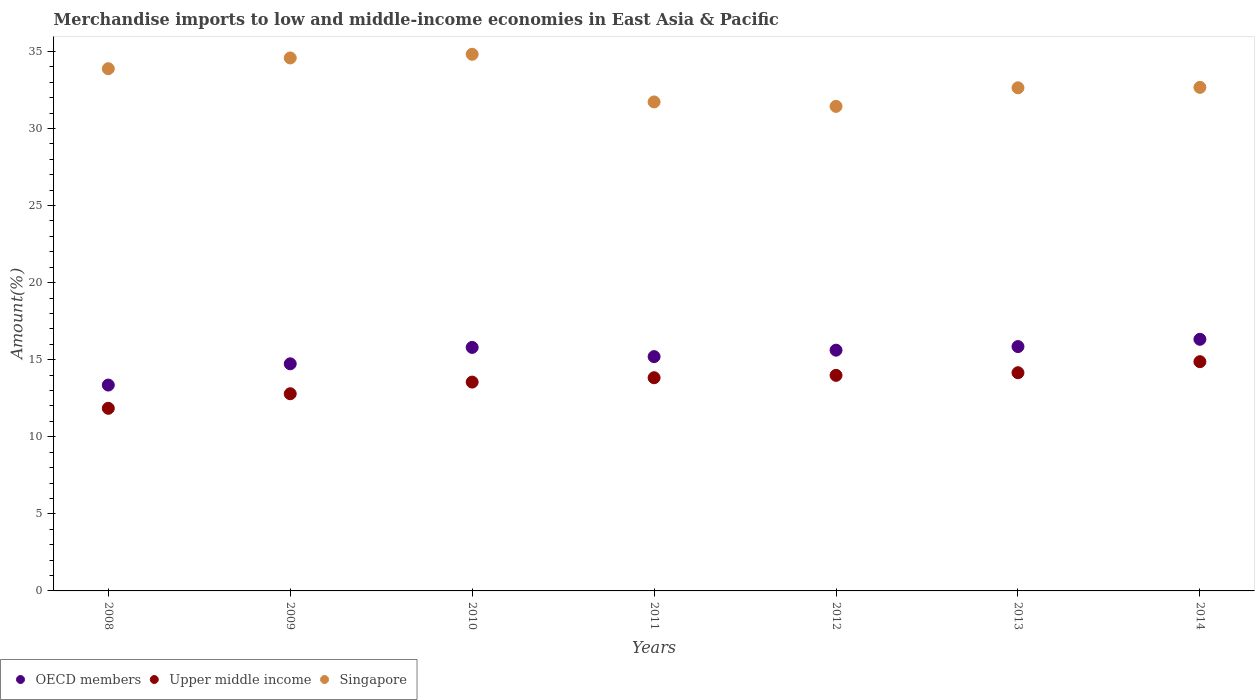Is the number of dotlines equal to the number of legend labels?
Provide a succinct answer. Yes. What is the percentage of amount earned from merchandise imports in Singapore in 2012?
Offer a terse response. 31.43. Across all years, what is the maximum percentage of amount earned from merchandise imports in OECD members?
Make the answer very short. 16.32. Across all years, what is the minimum percentage of amount earned from merchandise imports in Singapore?
Your answer should be very brief. 31.43. In which year was the percentage of amount earned from merchandise imports in Singapore maximum?
Ensure brevity in your answer.  2010. In which year was the percentage of amount earned from merchandise imports in OECD members minimum?
Your answer should be compact. 2008. What is the total percentage of amount earned from merchandise imports in OECD members in the graph?
Offer a terse response. 106.87. What is the difference between the percentage of amount earned from merchandise imports in OECD members in 2010 and that in 2011?
Provide a succinct answer. 0.6. What is the difference between the percentage of amount earned from merchandise imports in Upper middle income in 2012 and the percentage of amount earned from merchandise imports in OECD members in 2009?
Keep it short and to the point. -0.75. What is the average percentage of amount earned from merchandise imports in OECD members per year?
Give a very brief answer. 15.27. In the year 2008, what is the difference between the percentage of amount earned from merchandise imports in Singapore and percentage of amount earned from merchandise imports in Upper middle income?
Your answer should be very brief. 22.03. What is the ratio of the percentage of amount earned from merchandise imports in Upper middle income in 2010 to that in 2011?
Provide a succinct answer. 0.98. What is the difference between the highest and the second highest percentage of amount earned from merchandise imports in OECD members?
Your answer should be compact. 0.47. What is the difference between the highest and the lowest percentage of amount earned from merchandise imports in Singapore?
Ensure brevity in your answer.  3.38. Does the percentage of amount earned from merchandise imports in OECD members monotonically increase over the years?
Your answer should be very brief. No. Is the percentage of amount earned from merchandise imports in OECD members strictly greater than the percentage of amount earned from merchandise imports in Singapore over the years?
Provide a succinct answer. No. Is the percentage of amount earned from merchandise imports in Upper middle income strictly less than the percentage of amount earned from merchandise imports in Singapore over the years?
Your answer should be compact. Yes. How many dotlines are there?
Your response must be concise. 3. How are the legend labels stacked?
Your answer should be very brief. Horizontal. What is the title of the graph?
Your answer should be very brief. Merchandise imports to low and middle-income economies in East Asia & Pacific. What is the label or title of the Y-axis?
Ensure brevity in your answer.  Amount(%). What is the Amount(%) in OECD members in 2008?
Your answer should be compact. 13.35. What is the Amount(%) of Upper middle income in 2008?
Give a very brief answer. 11.85. What is the Amount(%) in Singapore in 2008?
Ensure brevity in your answer.  33.87. What is the Amount(%) in OECD members in 2009?
Your answer should be compact. 14.73. What is the Amount(%) of Upper middle income in 2009?
Your answer should be compact. 12.79. What is the Amount(%) in Singapore in 2009?
Give a very brief answer. 34.57. What is the Amount(%) in OECD members in 2010?
Offer a very short reply. 15.8. What is the Amount(%) of Upper middle income in 2010?
Your answer should be compact. 13.55. What is the Amount(%) in Singapore in 2010?
Your response must be concise. 34.81. What is the Amount(%) of OECD members in 2011?
Make the answer very short. 15.2. What is the Amount(%) of Upper middle income in 2011?
Your answer should be very brief. 13.83. What is the Amount(%) in Singapore in 2011?
Keep it short and to the point. 31.72. What is the Amount(%) of OECD members in 2012?
Provide a succinct answer. 15.62. What is the Amount(%) of Upper middle income in 2012?
Ensure brevity in your answer.  13.98. What is the Amount(%) of Singapore in 2012?
Give a very brief answer. 31.43. What is the Amount(%) in OECD members in 2013?
Your answer should be compact. 15.85. What is the Amount(%) of Upper middle income in 2013?
Provide a succinct answer. 14.15. What is the Amount(%) in Singapore in 2013?
Offer a very short reply. 32.63. What is the Amount(%) of OECD members in 2014?
Make the answer very short. 16.32. What is the Amount(%) in Upper middle income in 2014?
Make the answer very short. 14.87. What is the Amount(%) of Singapore in 2014?
Your response must be concise. 32.66. Across all years, what is the maximum Amount(%) in OECD members?
Give a very brief answer. 16.32. Across all years, what is the maximum Amount(%) of Upper middle income?
Offer a terse response. 14.87. Across all years, what is the maximum Amount(%) of Singapore?
Provide a succinct answer. 34.81. Across all years, what is the minimum Amount(%) in OECD members?
Ensure brevity in your answer.  13.35. Across all years, what is the minimum Amount(%) in Upper middle income?
Ensure brevity in your answer.  11.85. Across all years, what is the minimum Amount(%) of Singapore?
Make the answer very short. 31.43. What is the total Amount(%) in OECD members in the graph?
Your answer should be very brief. 106.87. What is the total Amount(%) in Upper middle income in the graph?
Your answer should be compact. 95.02. What is the total Amount(%) in Singapore in the graph?
Your response must be concise. 231.7. What is the difference between the Amount(%) in OECD members in 2008 and that in 2009?
Make the answer very short. -1.38. What is the difference between the Amount(%) of Upper middle income in 2008 and that in 2009?
Make the answer very short. -0.94. What is the difference between the Amount(%) in Singapore in 2008 and that in 2009?
Give a very brief answer. -0.7. What is the difference between the Amount(%) in OECD members in 2008 and that in 2010?
Give a very brief answer. -2.44. What is the difference between the Amount(%) in Upper middle income in 2008 and that in 2010?
Keep it short and to the point. -1.7. What is the difference between the Amount(%) of Singapore in 2008 and that in 2010?
Make the answer very short. -0.94. What is the difference between the Amount(%) in OECD members in 2008 and that in 2011?
Provide a short and direct response. -1.84. What is the difference between the Amount(%) in Upper middle income in 2008 and that in 2011?
Your answer should be compact. -1.98. What is the difference between the Amount(%) in Singapore in 2008 and that in 2011?
Keep it short and to the point. 2.16. What is the difference between the Amount(%) of OECD members in 2008 and that in 2012?
Make the answer very short. -2.26. What is the difference between the Amount(%) of Upper middle income in 2008 and that in 2012?
Make the answer very short. -2.14. What is the difference between the Amount(%) of Singapore in 2008 and that in 2012?
Your answer should be compact. 2.44. What is the difference between the Amount(%) in OECD members in 2008 and that in 2013?
Your answer should be compact. -2.5. What is the difference between the Amount(%) of Upper middle income in 2008 and that in 2013?
Your response must be concise. -2.31. What is the difference between the Amount(%) of Singapore in 2008 and that in 2013?
Offer a terse response. 1.24. What is the difference between the Amount(%) of OECD members in 2008 and that in 2014?
Your answer should be very brief. -2.97. What is the difference between the Amount(%) of Upper middle income in 2008 and that in 2014?
Give a very brief answer. -3.02. What is the difference between the Amount(%) in Singapore in 2008 and that in 2014?
Your answer should be very brief. 1.21. What is the difference between the Amount(%) in OECD members in 2009 and that in 2010?
Provide a short and direct response. -1.06. What is the difference between the Amount(%) of Upper middle income in 2009 and that in 2010?
Provide a short and direct response. -0.76. What is the difference between the Amount(%) of Singapore in 2009 and that in 2010?
Offer a terse response. -0.24. What is the difference between the Amount(%) in OECD members in 2009 and that in 2011?
Give a very brief answer. -0.47. What is the difference between the Amount(%) of Upper middle income in 2009 and that in 2011?
Your answer should be compact. -1.04. What is the difference between the Amount(%) in Singapore in 2009 and that in 2011?
Your answer should be very brief. 2.85. What is the difference between the Amount(%) of OECD members in 2009 and that in 2012?
Your answer should be very brief. -0.88. What is the difference between the Amount(%) in Upper middle income in 2009 and that in 2012?
Offer a very short reply. -1.19. What is the difference between the Amount(%) of Singapore in 2009 and that in 2012?
Make the answer very short. 3.14. What is the difference between the Amount(%) of OECD members in 2009 and that in 2013?
Make the answer very short. -1.12. What is the difference between the Amount(%) of Upper middle income in 2009 and that in 2013?
Make the answer very short. -1.36. What is the difference between the Amount(%) of Singapore in 2009 and that in 2013?
Your answer should be compact. 1.94. What is the difference between the Amount(%) in OECD members in 2009 and that in 2014?
Give a very brief answer. -1.59. What is the difference between the Amount(%) of Upper middle income in 2009 and that in 2014?
Your response must be concise. -2.08. What is the difference between the Amount(%) of Singapore in 2009 and that in 2014?
Your answer should be compact. 1.91. What is the difference between the Amount(%) in OECD members in 2010 and that in 2011?
Provide a short and direct response. 0.6. What is the difference between the Amount(%) in Upper middle income in 2010 and that in 2011?
Keep it short and to the point. -0.28. What is the difference between the Amount(%) in Singapore in 2010 and that in 2011?
Your answer should be compact. 3.09. What is the difference between the Amount(%) of OECD members in 2010 and that in 2012?
Your answer should be very brief. 0.18. What is the difference between the Amount(%) of Upper middle income in 2010 and that in 2012?
Make the answer very short. -0.44. What is the difference between the Amount(%) of Singapore in 2010 and that in 2012?
Keep it short and to the point. 3.38. What is the difference between the Amount(%) in OECD members in 2010 and that in 2013?
Your response must be concise. -0.05. What is the difference between the Amount(%) of Upper middle income in 2010 and that in 2013?
Your answer should be very brief. -0.61. What is the difference between the Amount(%) in Singapore in 2010 and that in 2013?
Ensure brevity in your answer.  2.17. What is the difference between the Amount(%) in OECD members in 2010 and that in 2014?
Provide a succinct answer. -0.53. What is the difference between the Amount(%) in Upper middle income in 2010 and that in 2014?
Ensure brevity in your answer.  -1.32. What is the difference between the Amount(%) in Singapore in 2010 and that in 2014?
Give a very brief answer. 2.15. What is the difference between the Amount(%) of OECD members in 2011 and that in 2012?
Keep it short and to the point. -0.42. What is the difference between the Amount(%) in Upper middle income in 2011 and that in 2012?
Your response must be concise. -0.15. What is the difference between the Amount(%) of Singapore in 2011 and that in 2012?
Keep it short and to the point. 0.29. What is the difference between the Amount(%) of OECD members in 2011 and that in 2013?
Give a very brief answer. -0.65. What is the difference between the Amount(%) of Upper middle income in 2011 and that in 2013?
Your response must be concise. -0.32. What is the difference between the Amount(%) of Singapore in 2011 and that in 2013?
Make the answer very short. -0.92. What is the difference between the Amount(%) in OECD members in 2011 and that in 2014?
Offer a terse response. -1.12. What is the difference between the Amount(%) in Upper middle income in 2011 and that in 2014?
Your answer should be compact. -1.04. What is the difference between the Amount(%) in Singapore in 2011 and that in 2014?
Give a very brief answer. -0.94. What is the difference between the Amount(%) in OECD members in 2012 and that in 2013?
Your response must be concise. -0.23. What is the difference between the Amount(%) in Upper middle income in 2012 and that in 2013?
Your response must be concise. -0.17. What is the difference between the Amount(%) of Singapore in 2012 and that in 2013?
Your response must be concise. -1.2. What is the difference between the Amount(%) of OECD members in 2012 and that in 2014?
Keep it short and to the point. -0.71. What is the difference between the Amount(%) of Upper middle income in 2012 and that in 2014?
Your response must be concise. -0.89. What is the difference between the Amount(%) in Singapore in 2012 and that in 2014?
Ensure brevity in your answer.  -1.23. What is the difference between the Amount(%) of OECD members in 2013 and that in 2014?
Ensure brevity in your answer.  -0.47. What is the difference between the Amount(%) in Upper middle income in 2013 and that in 2014?
Offer a terse response. -0.72. What is the difference between the Amount(%) in Singapore in 2013 and that in 2014?
Your answer should be compact. -0.03. What is the difference between the Amount(%) of OECD members in 2008 and the Amount(%) of Upper middle income in 2009?
Offer a terse response. 0.56. What is the difference between the Amount(%) of OECD members in 2008 and the Amount(%) of Singapore in 2009?
Make the answer very short. -21.22. What is the difference between the Amount(%) of Upper middle income in 2008 and the Amount(%) of Singapore in 2009?
Give a very brief answer. -22.73. What is the difference between the Amount(%) in OECD members in 2008 and the Amount(%) in Upper middle income in 2010?
Provide a succinct answer. -0.19. What is the difference between the Amount(%) in OECD members in 2008 and the Amount(%) in Singapore in 2010?
Your answer should be very brief. -21.46. What is the difference between the Amount(%) in Upper middle income in 2008 and the Amount(%) in Singapore in 2010?
Your response must be concise. -22.96. What is the difference between the Amount(%) of OECD members in 2008 and the Amount(%) of Upper middle income in 2011?
Give a very brief answer. -0.47. What is the difference between the Amount(%) of OECD members in 2008 and the Amount(%) of Singapore in 2011?
Make the answer very short. -18.36. What is the difference between the Amount(%) in Upper middle income in 2008 and the Amount(%) in Singapore in 2011?
Keep it short and to the point. -19.87. What is the difference between the Amount(%) in OECD members in 2008 and the Amount(%) in Upper middle income in 2012?
Offer a terse response. -0.63. What is the difference between the Amount(%) of OECD members in 2008 and the Amount(%) of Singapore in 2012?
Ensure brevity in your answer.  -18.08. What is the difference between the Amount(%) in Upper middle income in 2008 and the Amount(%) in Singapore in 2012?
Provide a short and direct response. -19.58. What is the difference between the Amount(%) in OECD members in 2008 and the Amount(%) in Upper middle income in 2013?
Offer a very short reply. -0.8. What is the difference between the Amount(%) in OECD members in 2008 and the Amount(%) in Singapore in 2013?
Your answer should be very brief. -19.28. What is the difference between the Amount(%) of Upper middle income in 2008 and the Amount(%) of Singapore in 2013?
Give a very brief answer. -20.79. What is the difference between the Amount(%) in OECD members in 2008 and the Amount(%) in Upper middle income in 2014?
Keep it short and to the point. -1.52. What is the difference between the Amount(%) of OECD members in 2008 and the Amount(%) of Singapore in 2014?
Your answer should be compact. -19.31. What is the difference between the Amount(%) of Upper middle income in 2008 and the Amount(%) of Singapore in 2014?
Your response must be concise. -20.82. What is the difference between the Amount(%) of OECD members in 2009 and the Amount(%) of Upper middle income in 2010?
Provide a short and direct response. 1.19. What is the difference between the Amount(%) of OECD members in 2009 and the Amount(%) of Singapore in 2010?
Make the answer very short. -20.08. What is the difference between the Amount(%) in Upper middle income in 2009 and the Amount(%) in Singapore in 2010?
Provide a succinct answer. -22.02. What is the difference between the Amount(%) of OECD members in 2009 and the Amount(%) of Upper middle income in 2011?
Offer a terse response. 0.9. What is the difference between the Amount(%) of OECD members in 2009 and the Amount(%) of Singapore in 2011?
Offer a very short reply. -16.99. What is the difference between the Amount(%) of Upper middle income in 2009 and the Amount(%) of Singapore in 2011?
Provide a short and direct response. -18.93. What is the difference between the Amount(%) in OECD members in 2009 and the Amount(%) in Upper middle income in 2012?
Offer a terse response. 0.75. What is the difference between the Amount(%) in OECD members in 2009 and the Amount(%) in Singapore in 2012?
Your answer should be very brief. -16.7. What is the difference between the Amount(%) of Upper middle income in 2009 and the Amount(%) of Singapore in 2012?
Offer a very short reply. -18.64. What is the difference between the Amount(%) of OECD members in 2009 and the Amount(%) of Upper middle income in 2013?
Make the answer very short. 0.58. What is the difference between the Amount(%) in OECD members in 2009 and the Amount(%) in Singapore in 2013?
Provide a succinct answer. -17.9. What is the difference between the Amount(%) in Upper middle income in 2009 and the Amount(%) in Singapore in 2013?
Your answer should be compact. -19.84. What is the difference between the Amount(%) of OECD members in 2009 and the Amount(%) of Upper middle income in 2014?
Your answer should be compact. -0.14. What is the difference between the Amount(%) in OECD members in 2009 and the Amount(%) in Singapore in 2014?
Your answer should be very brief. -17.93. What is the difference between the Amount(%) in Upper middle income in 2009 and the Amount(%) in Singapore in 2014?
Make the answer very short. -19.87. What is the difference between the Amount(%) in OECD members in 2010 and the Amount(%) in Upper middle income in 2011?
Offer a very short reply. 1.97. What is the difference between the Amount(%) of OECD members in 2010 and the Amount(%) of Singapore in 2011?
Your answer should be compact. -15.92. What is the difference between the Amount(%) in Upper middle income in 2010 and the Amount(%) in Singapore in 2011?
Give a very brief answer. -18.17. What is the difference between the Amount(%) of OECD members in 2010 and the Amount(%) of Upper middle income in 2012?
Keep it short and to the point. 1.81. What is the difference between the Amount(%) in OECD members in 2010 and the Amount(%) in Singapore in 2012?
Offer a terse response. -15.63. What is the difference between the Amount(%) of Upper middle income in 2010 and the Amount(%) of Singapore in 2012?
Your response must be concise. -17.88. What is the difference between the Amount(%) of OECD members in 2010 and the Amount(%) of Upper middle income in 2013?
Give a very brief answer. 1.64. What is the difference between the Amount(%) of OECD members in 2010 and the Amount(%) of Singapore in 2013?
Make the answer very short. -16.84. What is the difference between the Amount(%) in Upper middle income in 2010 and the Amount(%) in Singapore in 2013?
Give a very brief answer. -19.09. What is the difference between the Amount(%) of OECD members in 2010 and the Amount(%) of Upper middle income in 2014?
Provide a succinct answer. 0.93. What is the difference between the Amount(%) of OECD members in 2010 and the Amount(%) of Singapore in 2014?
Your answer should be very brief. -16.87. What is the difference between the Amount(%) of Upper middle income in 2010 and the Amount(%) of Singapore in 2014?
Your answer should be very brief. -19.12. What is the difference between the Amount(%) of OECD members in 2011 and the Amount(%) of Upper middle income in 2012?
Your answer should be very brief. 1.21. What is the difference between the Amount(%) of OECD members in 2011 and the Amount(%) of Singapore in 2012?
Ensure brevity in your answer.  -16.23. What is the difference between the Amount(%) in Upper middle income in 2011 and the Amount(%) in Singapore in 2012?
Your answer should be compact. -17.6. What is the difference between the Amount(%) of OECD members in 2011 and the Amount(%) of Upper middle income in 2013?
Offer a very short reply. 1.05. What is the difference between the Amount(%) of OECD members in 2011 and the Amount(%) of Singapore in 2013?
Give a very brief answer. -17.44. What is the difference between the Amount(%) of Upper middle income in 2011 and the Amount(%) of Singapore in 2013?
Offer a very short reply. -18.81. What is the difference between the Amount(%) of OECD members in 2011 and the Amount(%) of Upper middle income in 2014?
Your answer should be compact. 0.33. What is the difference between the Amount(%) in OECD members in 2011 and the Amount(%) in Singapore in 2014?
Give a very brief answer. -17.46. What is the difference between the Amount(%) of Upper middle income in 2011 and the Amount(%) of Singapore in 2014?
Offer a very short reply. -18.83. What is the difference between the Amount(%) in OECD members in 2012 and the Amount(%) in Upper middle income in 2013?
Offer a terse response. 1.46. What is the difference between the Amount(%) in OECD members in 2012 and the Amount(%) in Singapore in 2013?
Provide a short and direct response. -17.02. What is the difference between the Amount(%) in Upper middle income in 2012 and the Amount(%) in Singapore in 2013?
Make the answer very short. -18.65. What is the difference between the Amount(%) in OECD members in 2012 and the Amount(%) in Upper middle income in 2014?
Give a very brief answer. 0.75. What is the difference between the Amount(%) of OECD members in 2012 and the Amount(%) of Singapore in 2014?
Provide a succinct answer. -17.05. What is the difference between the Amount(%) in Upper middle income in 2012 and the Amount(%) in Singapore in 2014?
Keep it short and to the point. -18.68. What is the difference between the Amount(%) of OECD members in 2013 and the Amount(%) of Upper middle income in 2014?
Offer a terse response. 0.98. What is the difference between the Amount(%) of OECD members in 2013 and the Amount(%) of Singapore in 2014?
Your answer should be very brief. -16.81. What is the difference between the Amount(%) in Upper middle income in 2013 and the Amount(%) in Singapore in 2014?
Offer a terse response. -18.51. What is the average Amount(%) in OECD members per year?
Make the answer very short. 15.27. What is the average Amount(%) of Upper middle income per year?
Provide a short and direct response. 13.57. What is the average Amount(%) of Singapore per year?
Keep it short and to the point. 33.1. In the year 2008, what is the difference between the Amount(%) in OECD members and Amount(%) in Upper middle income?
Give a very brief answer. 1.51. In the year 2008, what is the difference between the Amount(%) in OECD members and Amount(%) in Singapore?
Offer a very short reply. -20.52. In the year 2008, what is the difference between the Amount(%) of Upper middle income and Amount(%) of Singapore?
Offer a terse response. -22.03. In the year 2009, what is the difference between the Amount(%) of OECD members and Amount(%) of Upper middle income?
Provide a short and direct response. 1.94. In the year 2009, what is the difference between the Amount(%) of OECD members and Amount(%) of Singapore?
Ensure brevity in your answer.  -19.84. In the year 2009, what is the difference between the Amount(%) of Upper middle income and Amount(%) of Singapore?
Your answer should be very brief. -21.78. In the year 2010, what is the difference between the Amount(%) in OECD members and Amount(%) in Upper middle income?
Ensure brevity in your answer.  2.25. In the year 2010, what is the difference between the Amount(%) of OECD members and Amount(%) of Singapore?
Provide a succinct answer. -19.01. In the year 2010, what is the difference between the Amount(%) of Upper middle income and Amount(%) of Singapore?
Provide a short and direct response. -21.26. In the year 2011, what is the difference between the Amount(%) in OECD members and Amount(%) in Upper middle income?
Provide a succinct answer. 1.37. In the year 2011, what is the difference between the Amount(%) in OECD members and Amount(%) in Singapore?
Offer a very short reply. -16.52. In the year 2011, what is the difference between the Amount(%) in Upper middle income and Amount(%) in Singapore?
Give a very brief answer. -17.89. In the year 2012, what is the difference between the Amount(%) in OECD members and Amount(%) in Upper middle income?
Provide a succinct answer. 1.63. In the year 2012, what is the difference between the Amount(%) of OECD members and Amount(%) of Singapore?
Your answer should be very brief. -15.81. In the year 2012, what is the difference between the Amount(%) in Upper middle income and Amount(%) in Singapore?
Offer a terse response. -17.45. In the year 2013, what is the difference between the Amount(%) of OECD members and Amount(%) of Upper middle income?
Ensure brevity in your answer.  1.7. In the year 2013, what is the difference between the Amount(%) of OECD members and Amount(%) of Singapore?
Your answer should be compact. -16.79. In the year 2013, what is the difference between the Amount(%) in Upper middle income and Amount(%) in Singapore?
Ensure brevity in your answer.  -18.48. In the year 2014, what is the difference between the Amount(%) of OECD members and Amount(%) of Upper middle income?
Provide a short and direct response. 1.45. In the year 2014, what is the difference between the Amount(%) in OECD members and Amount(%) in Singapore?
Offer a very short reply. -16.34. In the year 2014, what is the difference between the Amount(%) of Upper middle income and Amount(%) of Singapore?
Your response must be concise. -17.79. What is the ratio of the Amount(%) in OECD members in 2008 to that in 2009?
Provide a succinct answer. 0.91. What is the ratio of the Amount(%) of Upper middle income in 2008 to that in 2009?
Offer a very short reply. 0.93. What is the ratio of the Amount(%) of Singapore in 2008 to that in 2009?
Your answer should be compact. 0.98. What is the ratio of the Amount(%) of OECD members in 2008 to that in 2010?
Your response must be concise. 0.85. What is the ratio of the Amount(%) in Upper middle income in 2008 to that in 2010?
Provide a short and direct response. 0.87. What is the ratio of the Amount(%) in Singapore in 2008 to that in 2010?
Your answer should be compact. 0.97. What is the ratio of the Amount(%) in OECD members in 2008 to that in 2011?
Keep it short and to the point. 0.88. What is the ratio of the Amount(%) of Upper middle income in 2008 to that in 2011?
Provide a succinct answer. 0.86. What is the ratio of the Amount(%) of Singapore in 2008 to that in 2011?
Make the answer very short. 1.07. What is the ratio of the Amount(%) of OECD members in 2008 to that in 2012?
Provide a short and direct response. 0.86. What is the ratio of the Amount(%) in Upper middle income in 2008 to that in 2012?
Give a very brief answer. 0.85. What is the ratio of the Amount(%) in Singapore in 2008 to that in 2012?
Give a very brief answer. 1.08. What is the ratio of the Amount(%) in OECD members in 2008 to that in 2013?
Provide a succinct answer. 0.84. What is the ratio of the Amount(%) of Upper middle income in 2008 to that in 2013?
Your answer should be very brief. 0.84. What is the ratio of the Amount(%) in Singapore in 2008 to that in 2013?
Provide a short and direct response. 1.04. What is the ratio of the Amount(%) of OECD members in 2008 to that in 2014?
Make the answer very short. 0.82. What is the ratio of the Amount(%) in Upper middle income in 2008 to that in 2014?
Ensure brevity in your answer.  0.8. What is the ratio of the Amount(%) of Singapore in 2008 to that in 2014?
Provide a succinct answer. 1.04. What is the ratio of the Amount(%) in OECD members in 2009 to that in 2010?
Make the answer very short. 0.93. What is the ratio of the Amount(%) in Upper middle income in 2009 to that in 2010?
Your answer should be compact. 0.94. What is the ratio of the Amount(%) of OECD members in 2009 to that in 2011?
Keep it short and to the point. 0.97. What is the ratio of the Amount(%) of Upper middle income in 2009 to that in 2011?
Give a very brief answer. 0.92. What is the ratio of the Amount(%) of Singapore in 2009 to that in 2011?
Offer a very short reply. 1.09. What is the ratio of the Amount(%) in OECD members in 2009 to that in 2012?
Provide a short and direct response. 0.94. What is the ratio of the Amount(%) of Upper middle income in 2009 to that in 2012?
Give a very brief answer. 0.91. What is the ratio of the Amount(%) of Singapore in 2009 to that in 2012?
Your response must be concise. 1.1. What is the ratio of the Amount(%) of OECD members in 2009 to that in 2013?
Provide a succinct answer. 0.93. What is the ratio of the Amount(%) in Upper middle income in 2009 to that in 2013?
Offer a very short reply. 0.9. What is the ratio of the Amount(%) in Singapore in 2009 to that in 2013?
Provide a succinct answer. 1.06. What is the ratio of the Amount(%) of OECD members in 2009 to that in 2014?
Your answer should be very brief. 0.9. What is the ratio of the Amount(%) in Upper middle income in 2009 to that in 2014?
Provide a succinct answer. 0.86. What is the ratio of the Amount(%) in Singapore in 2009 to that in 2014?
Ensure brevity in your answer.  1.06. What is the ratio of the Amount(%) in OECD members in 2010 to that in 2011?
Offer a very short reply. 1.04. What is the ratio of the Amount(%) of Upper middle income in 2010 to that in 2011?
Offer a terse response. 0.98. What is the ratio of the Amount(%) in Singapore in 2010 to that in 2011?
Offer a very short reply. 1.1. What is the ratio of the Amount(%) of OECD members in 2010 to that in 2012?
Your answer should be very brief. 1.01. What is the ratio of the Amount(%) of Upper middle income in 2010 to that in 2012?
Your response must be concise. 0.97. What is the ratio of the Amount(%) in Singapore in 2010 to that in 2012?
Your answer should be very brief. 1.11. What is the ratio of the Amount(%) in Upper middle income in 2010 to that in 2013?
Offer a very short reply. 0.96. What is the ratio of the Amount(%) in Singapore in 2010 to that in 2013?
Provide a short and direct response. 1.07. What is the ratio of the Amount(%) in Upper middle income in 2010 to that in 2014?
Keep it short and to the point. 0.91. What is the ratio of the Amount(%) of Singapore in 2010 to that in 2014?
Ensure brevity in your answer.  1.07. What is the ratio of the Amount(%) of OECD members in 2011 to that in 2012?
Ensure brevity in your answer.  0.97. What is the ratio of the Amount(%) of Upper middle income in 2011 to that in 2012?
Make the answer very short. 0.99. What is the ratio of the Amount(%) of Singapore in 2011 to that in 2012?
Keep it short and to the point. 1.01. What is the ratio of the Amount(%) of OECD members in 2011 to that in 2013?
Offer a terse response. 0.96. What is the ratio of the Amount(%) of Upper middle income in 2011 to that in 2013?
Offer a terse response. 0.98. What is the ratio of the Amount(%) of Singapore in 2011 to that in 2013?
Make the answer very short. 0.97. What is the ratio of the Amount(%) in OECD members in 2011 to that in 2014?
Make the answer very short. 0.93. What is the ratio of the Amount(%) in Upper middle income in 2011 to that in 2014?
Your answer should be very brief. 0.93. What is the ratio of the Amount(%) of Singapore in 2011 to that in 2014?
Your answer should be compact. 0.97. What is the ratio of the Amount(%) of Upper middle income in 2012 to that in 2013?
Your response must be concise. 0.99. What is the ratio of the Amount(%) of Singapore in 2012 to that in 2013?
Give a very brief answer. 0.96. What is the ratio of the Amount(%) in OECD members in 2012 to that in 2014?
Offer a terse response. 0.96. What is the ratio of the Amount(%) of Upper middle income in 2012 to that in 2014?
Provide a short and direct response. 0.94. What is the ratio of the Amount(%) of Singapore in 2012 to that in 2014?
Provide a succinct answer. 0.96. What is the ratio of the Amount(%) in Upper middle income in 2013 to that in 2014?
Provide a succinct answer. 0.95. What is the ratio of the Amount(%) in Singapore in 2013 to that in 2014?
Keep it short and to the point. 1. What is the difference between the highest and the second highest Amount(%) of OECD members?
Ensure brevity in your answer.  0.47. What is the difference between the highest and the second highest Amount(%) in Upper middle income?
Give a very brief answer. 0.72. What is the difference between the highest and the second highest Amount(%) of Singapore?
Offer a very short reply. 0.24. What is the difference between the highest and the lowest Amount(%) in OECD members?
Your response must be concise. 2.97. What is the difference between the highest and the lowest Amount(%) in Upper middle income?
Offer a terse response. 3.02. What is the difference between the highest and the lowest Amount(%) of Singapore?
Provide a short and direct response. 3.38. 